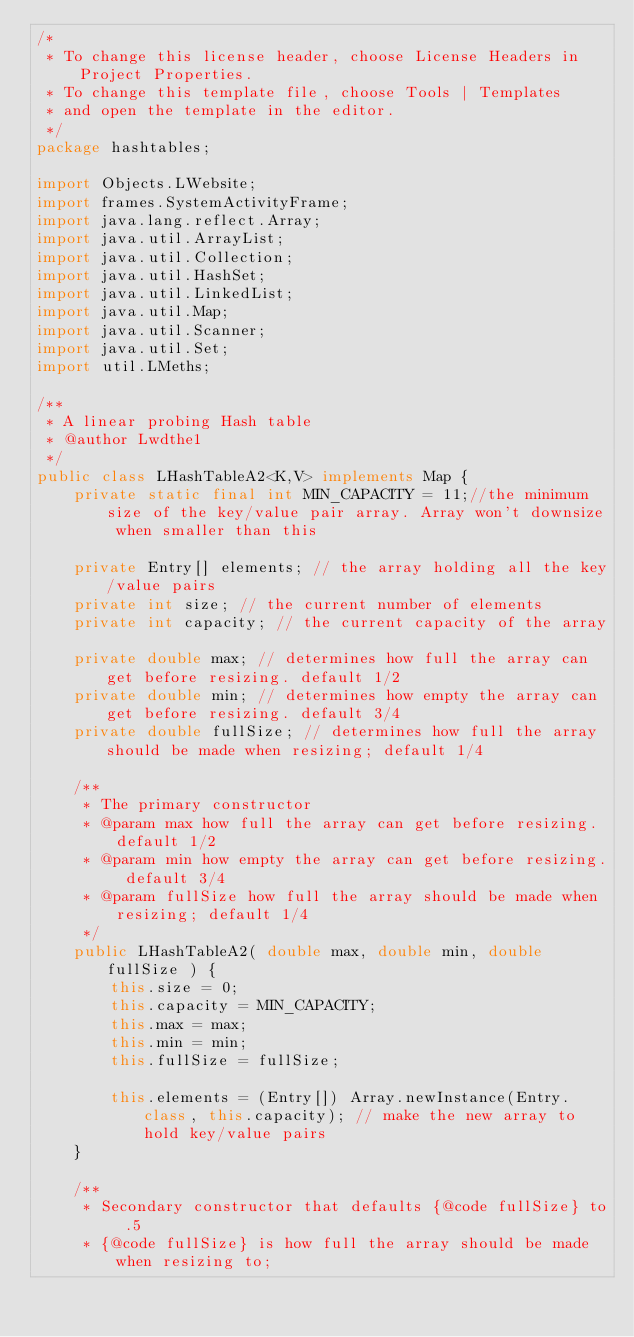Convert code to text. <code><loc_0><loc_0><loc_500><loc_500><_Java_>/*
 * To change this license header, choose License Headers in Project Properties.
 * To change this template file, choose Tools | Templates
 * and open the template in the editor.
 */
package hashtables;

import Objects.LWebsite;
import frames.SystemActivityFrame;
import java.lang.reflect.Array;
import java.util.ArrayList;
import java.util.Collection;
import java.util.HashSet;
import java.util.LinkedList;
import java.util.Map;
import java.util.Scanner;
import java.util.Set;
import util.LMeths;

/**
 * A linear probing Hash table
 * @author Lwdthe1
 */
public class LHashTableA2<K,V> implements Map {
    private static final int MIN_CAPACITY = 11;//the minimum size of the key/value pair array. Array won't downsize when smaller than this

    private Entry[] elements; // the array holding all the key/value pairs
    private int size; // the current number of elements
    private int capacity; // the current capacity of the array
    
    private double max; // determines how full the array can get before resizing. default 1/2
    private double min; // determines how empty the array can get before resizing. default 3/4
    private double fullSize; // determines how full the array should be made when resizing; default 1/4
    
    /**
     * The primary constructor
     * @param max how full the array can get before resizing. default 1/2
     * @param min how empty the array can get before resizing. default 3/4
     * @param fullSize how full the array should be made when resizing; default 1/4
     */
    public LHashTableA2( double max, double min, double fullSize ) {
        this.size = 0;
        this.capacity = MIN_CAPACITY;
        this.max = max;
        this.min = min;
        this.fullSize = fullSize;
        
        this.elements = (Entry[]) Array.newInstance(Entry.class, this.capacity); // make the new array to hold key/value pairs
    }
    
    /**
     * Secondary constructor that defaults {@code fullSize} to .5
     * {@code fullSize} is how full the array should be made when resizing to;</code> 